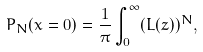Convert formula to latex. <formula><loc_0><loc_0><loc_500><loc_500>P _ { N } ( x = 0 ) = \frac { 1 } { \pi } \int _ { 0 } ^ { \infty } ( L ( z ) ) ^ { N } ,</formula> 